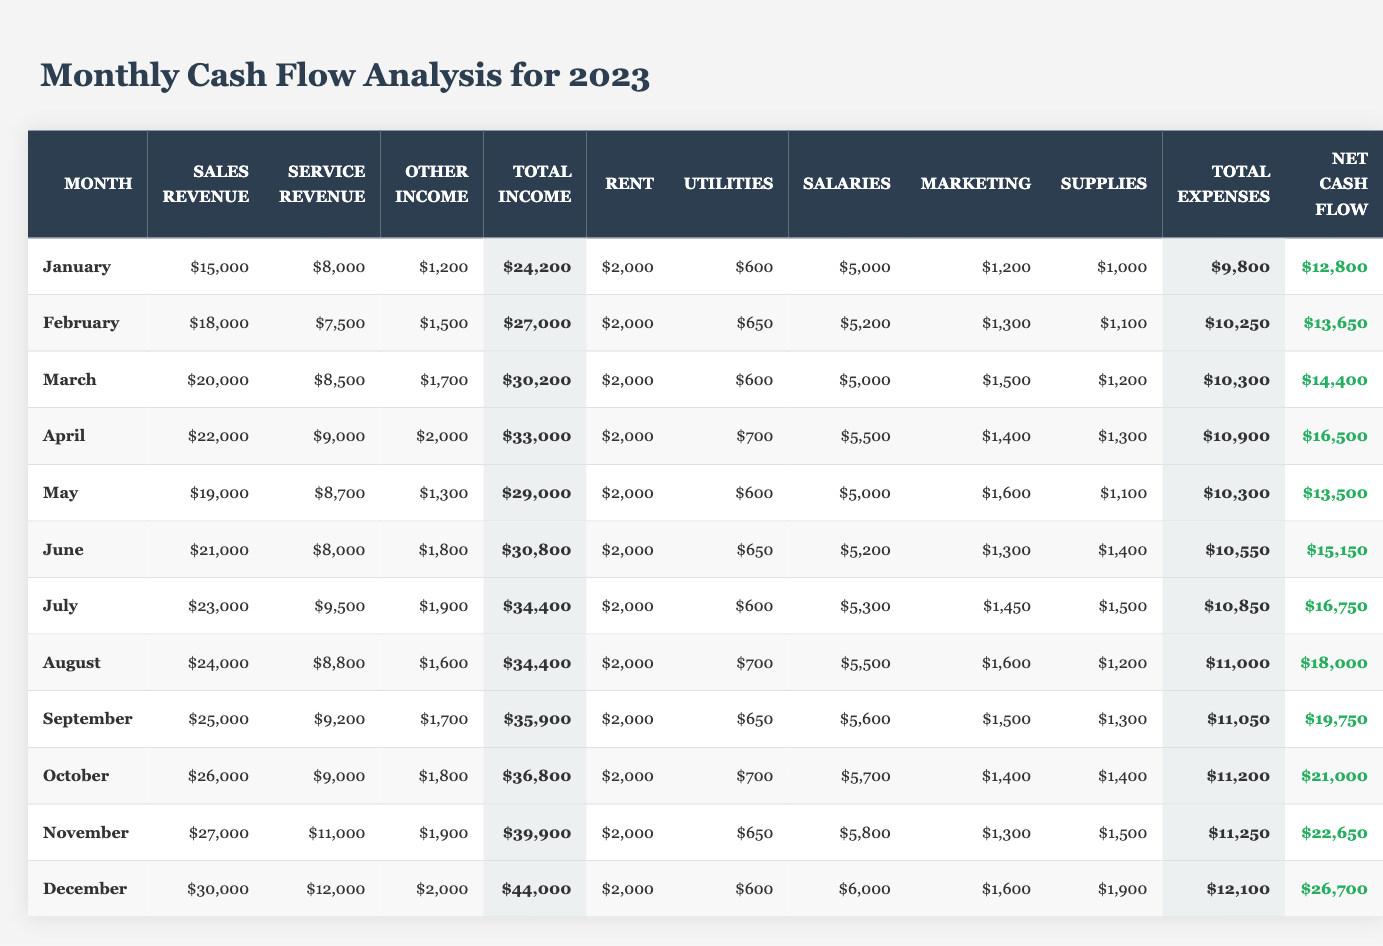What is the total income for December? In December, the total income is calculated by adding Sales Revenue ($30,000), Service Revenue ($12,000), and Other Income ($2,000). The sum is $30,000 + $12,000 + $2,000 = $44,000.
Answer: $44,000 What was the net cash flow in May? The net cash flow for May is directly provided in the table as $13,500.
Answer: $13,500 Which month had the highest net cash flow? December has the highest net cash flow of $26,700. By comparing all net cash flow values for each month, December is the maximum.
Answer: December What are the total expenses for October? Total expenses for October are determined by summing Rent ($2,000), Utilities ($700), Salaries ($5,700), Marketing ($1,400), and Supplies ($1,400). The total is $2,000 + $700 + $5,700 + $1,400 + $1,400 = $11,200.
Answer: $11,200 Was the service revenue in July higher than that in June? The service revenue for July is $9,500, while for June it is $8,000. Since $9,500 is greater than $8,000, the statement is true.
Answer: Yes Calculate the average net cash flow for the first quarter (January to March). The net cash flows for January, February, and March are $12,800, $13,650, and $14,400, respectively. To find the average: (12,800 + 13,650 + 14,400) / 3 = $40,850 / 3 = $13,616.67.
Answer: $13,616.67 What was the change in net cash flow from January to December? January's net cash flow is $12,800, and December's net cash flow is $26,700. The change is calculated as $26,700 - $12,800 = $13,900.
Answer: $13,900 Which month had total expenses exceeding $10,000? Analyzing each month’s total expenses reveals that April ($10,900), June ($10,550), July ($10,850), August ($11,000), September ($11,050), October ($11,200), November ($11,250), and December ($12,100) had expenses above $10,000.
Answer: April, June, July, August, September, October, November, December If rent remains constant, how much more does the business spend on supplies in December compared to January? In December, supplies cost $1,900, and in January, they cost $1,000. The difference is $1,900 - $1,000 = $900.
Answer: $900 What is the total sales revenue for the second half of the year (July to December)? The sales revenue for the second half is calculated by adding July ($23,000), August ($24,000), September ($25,000), October ($26,000), November ($27,000), and December ($30,000). The sum is: $23,000 + $24,000 + $25,000 + $26,000 + $27,000 + $30,000 = $155,000.
Answer: $155,000 